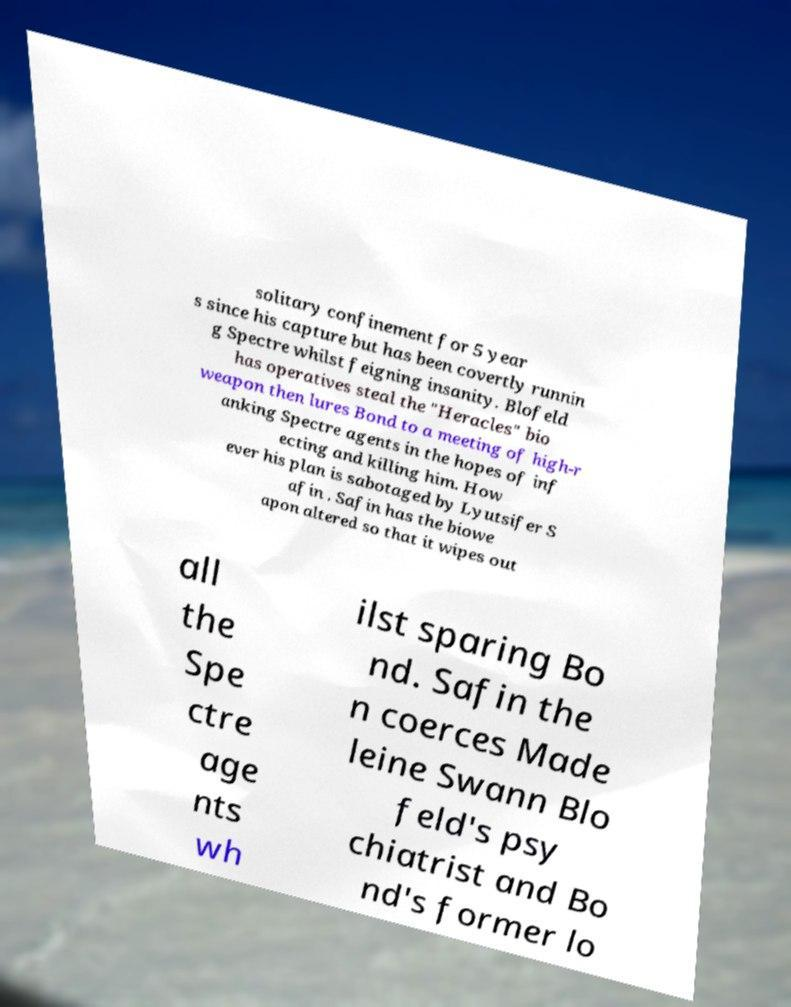Can you accurately transcribe the text from the provided image for me? solitary confinement for 5 year s since his capture but has been covertly runnin g Spectre whilst feigning insanity. Blofeld has operatives steal the "Heracles" bio weapon then lures Bond to a meeting of high-r anking Spectre agents in the hopes of inf ecting and killing him. How ever his plan is sabotaged by Lyutsifer S afin . Safin has the biowe apon altered so that it wipes out all the Spe ctre age nts wh ilst sparing Bo nd. Safin the n coerces Made leine Swann Blo feld's psy chiatrist and Bo nd's former lo 